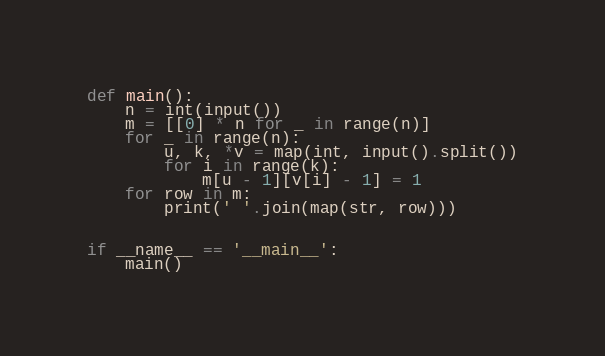Convert code to text. <code><loc_0><loc_0><loc_500><loc_500><_Python_>def main():
    n = int(input())
    m = [[0] * n for _ in range(n)]
    for _ in range(n):
        u, k, *v = map(int, input().split())
        for i in range(k):
            m[u - 1][v[i] - 1] = 1
    for row in m:
        print(' '.join(map(str, row)))


if __name__ == '__main__':
    main()

</code> 